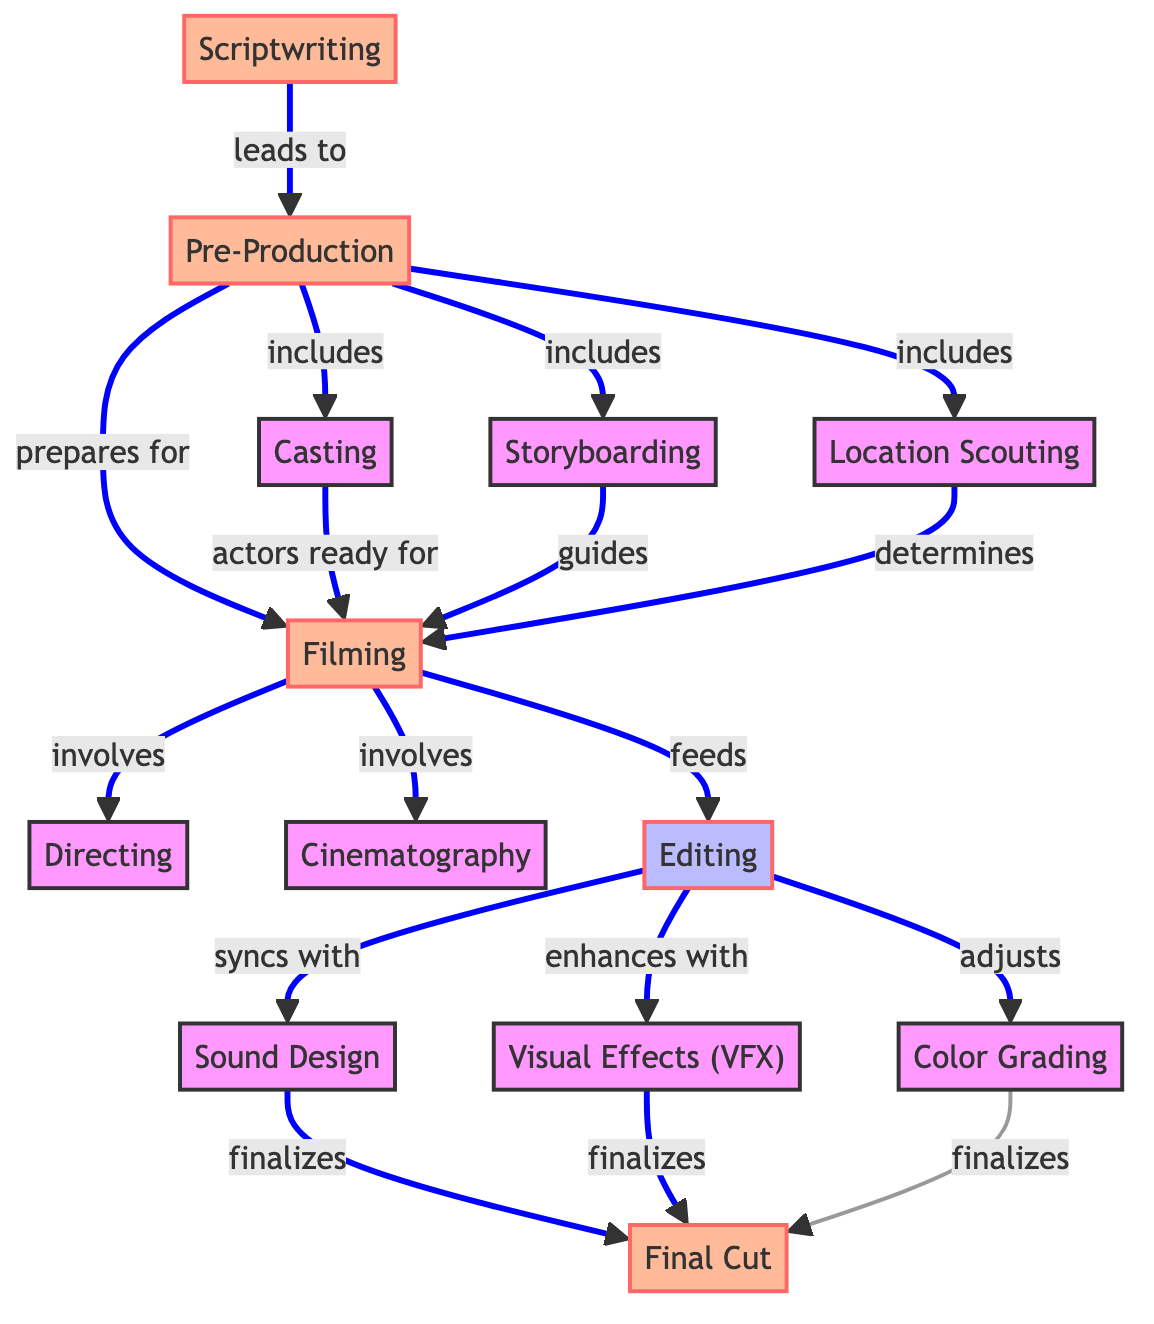What is the first phase in the workflow? The diagram starts with the "Scriptwriting" node, which is labeled as a phase in the film production workflow.
Answer: Scriptwriting How many phases are there in the workflow? Counting the nodes designated as phases, we have "Scriptwriting," "Pre-Production," "Filming," and "Final Cut," totaling four phases.
Answer: 4 Which role is involved in the "Filming" process? According to the diagram, both "Directing" and "Cinematography" are listed as roles that are involved during the "Filming" process.
Answer: Directing, Cinematography What does the "Editing" process sync with? The diagram indicates that the "Editing" process syncs with "Sound Design," highlighting the interdependent nature of these two stages.
Answer: Sound Design Which node feeds into "Editing"? The "Filming" node feeds into "Editing," signifying that footage captured during filming is the input for the editing process.
Answer: Filming What does "Color Grading" adjust? The diagram specifies that "Editing" adjusts "Color Grading," indicating the relationship where editing plays a role in fine-tuning the color aspects of the film.
Answer: Color Grading Which phase prepares for "Filming"? "Pre-Production" is the phase that prepares for "Filming," as indicated by the arrow leading to the filming stage from pre-production activities.
Answer: Pre-Production What is finalized by combining "Sound Design," "VFX," and "Color Grading"? The "Final Cut" is finalized by the combination of contributions from "Sound Design," "Visual Effects," and "Color Grading" processes.
Answer: Final Cut How many processes are represented in the workflow? The diagram shows three distinct processes: "Editing," "Sound Design," and "Visual Effects (VFX)," totaling three processes in the workflow.
Answer: 3 What guides the "Filming" process? "Storyboarding" guides the "Filming" process, making it a crucial element in visual planning for the shoot.
Answer: Storyboarding 